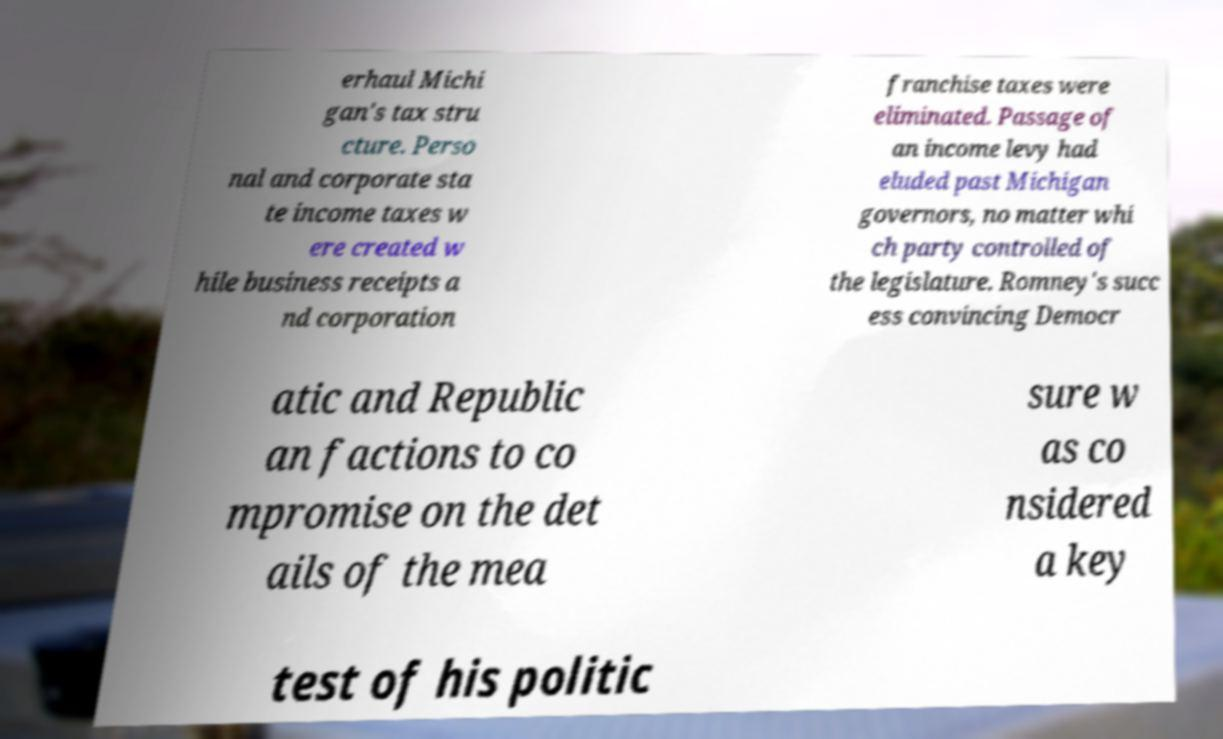Can you accurately transcribe the text from the provided image for me? erhaul Michi gan's tax stru cture. Perso nal and corporate sta te income taxes w ere created w hile business receipts a nd corporation franchise taxes were eliminated. Passage of an income levy had eluded past Michigan governors, no matter whi ch party controlled of the legislature. Romney's succ ess convincing Democr atic and Republic an factions to co mpromise on the det ails of the mea sure w as co nsidered a key test of his politic 